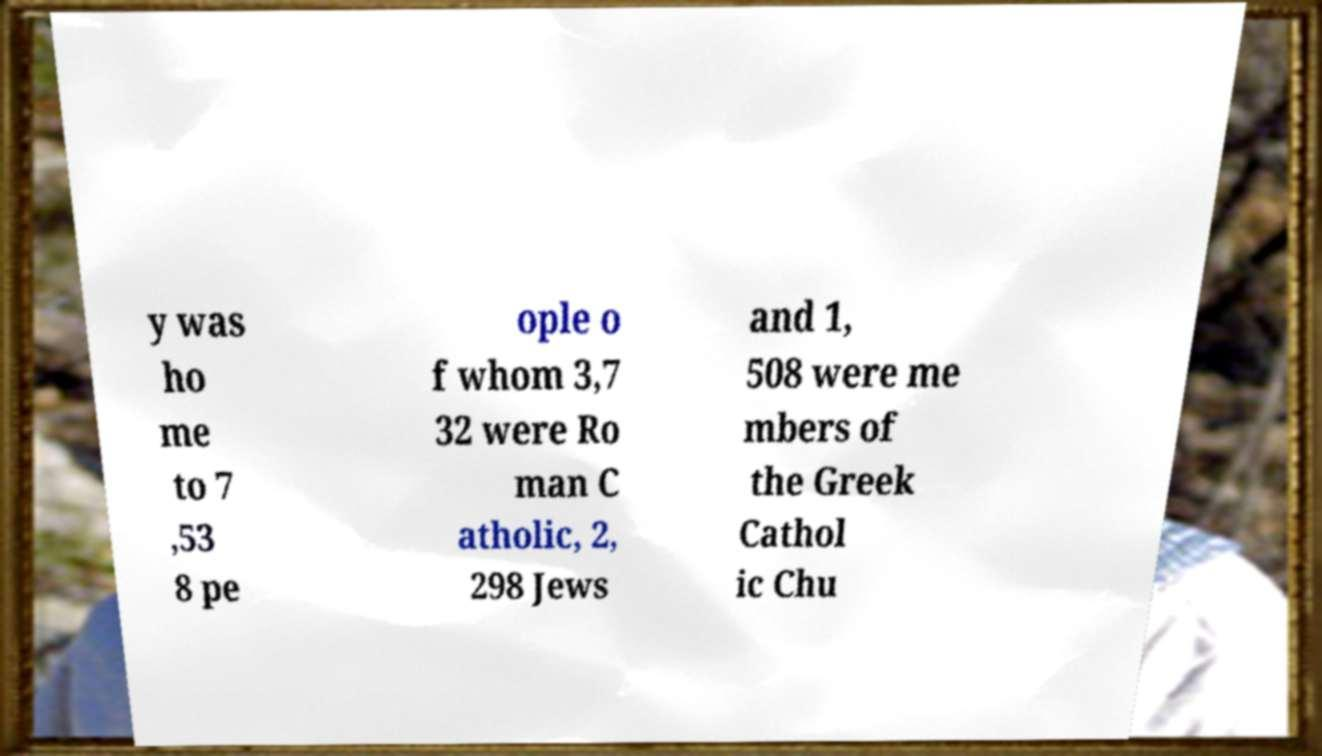Can you read and provide the text displayed in the image?This photo seems to have some interesting text. Can you extract and type it out for me? y was ho me to 7 ,53 8 pe ople o f whom 3,7 32 were Ro man C atholic, 2, 298 Jews and 1, 508 were me mbers of the Greek Cathol ic Chu 